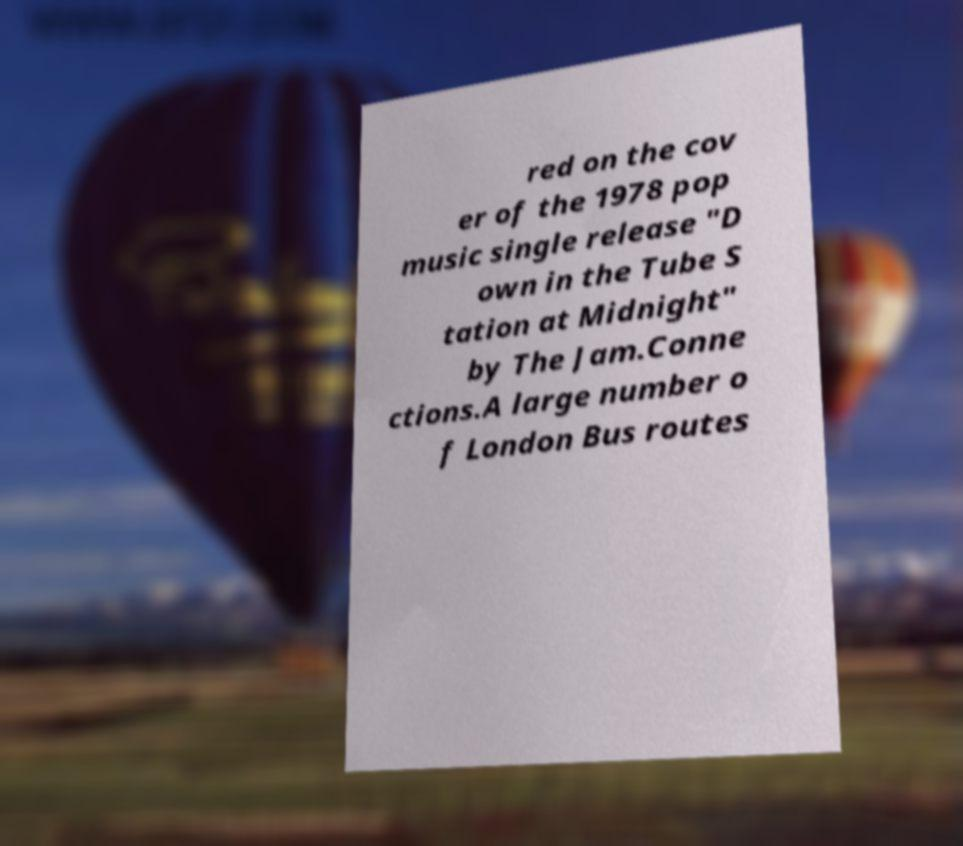Please identify and transcribe the text found in this image. red on the cov er of the 1978 pop music single release "D own in the Tube S tation at Midnight" by The Jam.Conne ctions.A large number o f London Bus routes 